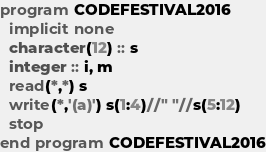Convert code to text. <code><loc_0><loc_0><loc_500><loc_500><_FORTRAN_>program CODEFESTIVAL2016
  implicit none
  character(12) :: s
  integer :: i, m
  read(*,*) s
  write(*,'(a)') s(1:4)//" "//s(5:12)
  stop
end program CODEFESTIVAL2016</code> 